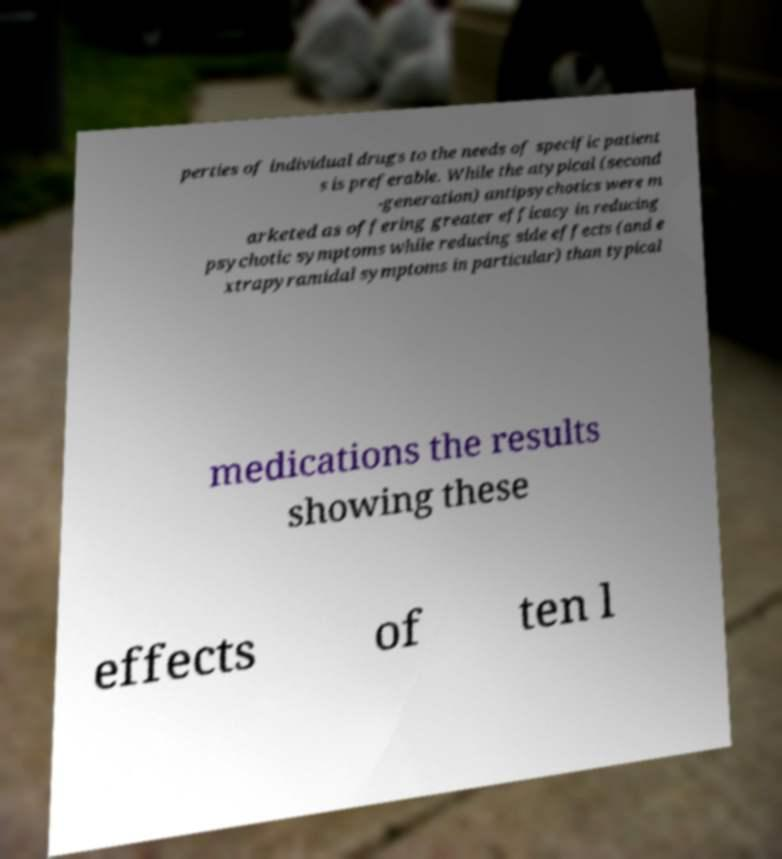Can you accurately transcribe the text from the provided image for me? perties of individual drugs to the needs of specific patient s is preferable. While the atypical (second -generation) antipsychotics were m arketed as offering greater efficacy in reducing psychotic symptoms while reducing side effects (and e xtrapyramidal symptoms in particular) than typical medications the results showing these effects of ten l 